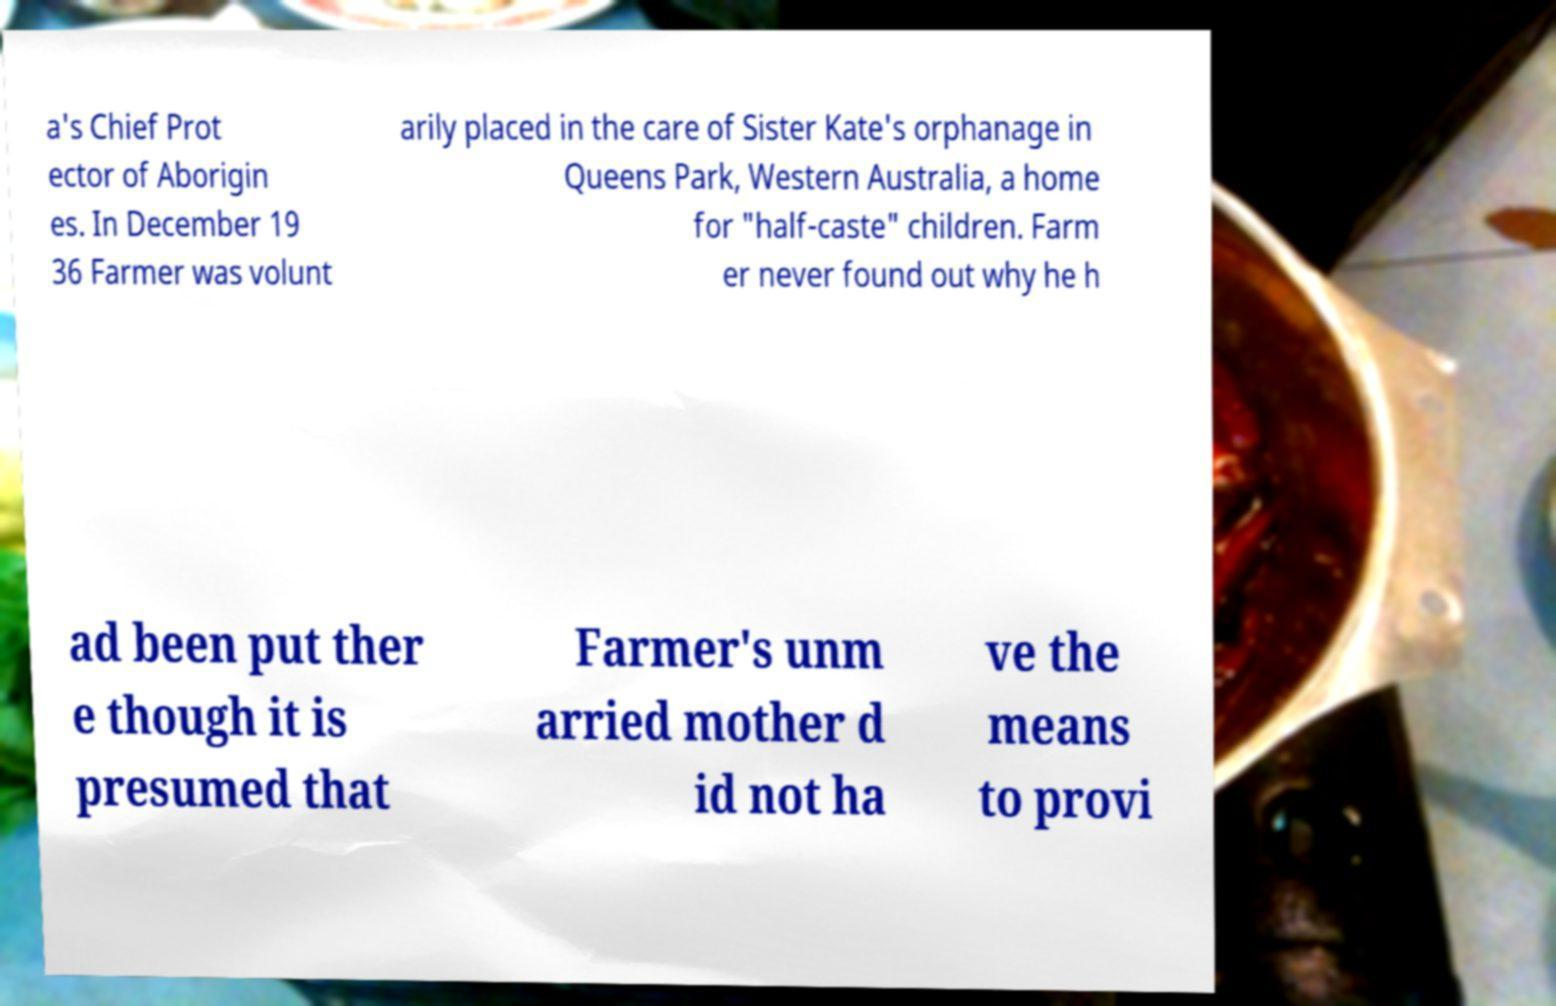Can you accurately transcribe the text from the provided image for me? a's Chief Prot ector of Aborigin es. In December 19 36 Farmer was volunt arily placed in the care of Sister Kate's orphanage in Queens Park, Western Australia, a home for "half-caste" children. Farm er never found out why he h ad been put ther e though it is presumed that Farmer's unm arried mother d id not ha ve the means to provi 